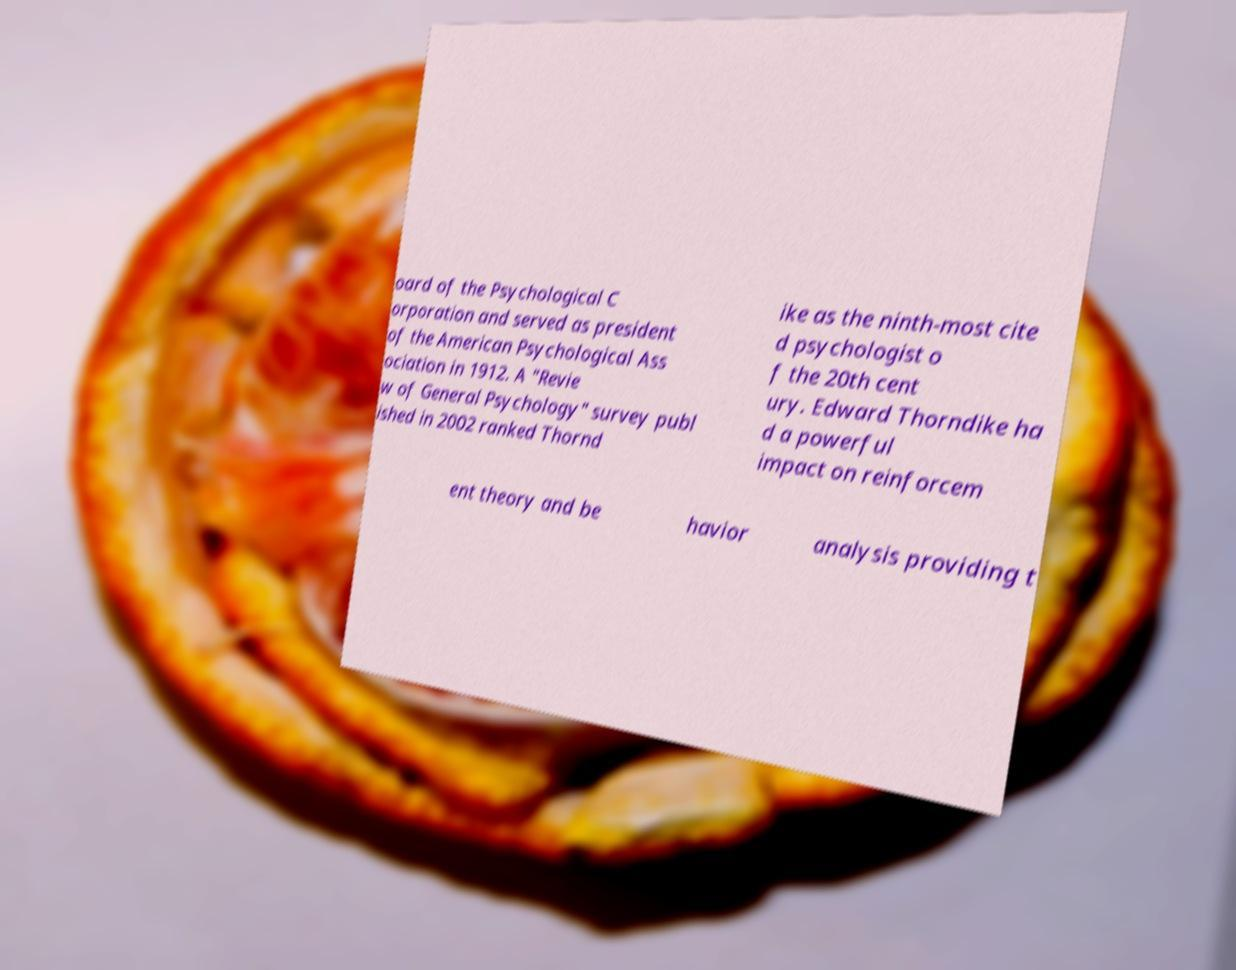Can you read and provide the text displayed in the image?This photo seems to have some interesting text. Can you extract and type it out for me? oard of the Psychological C orporation and served as president of the American Psychological Ass ociation in 1912. A "Revie w of General Psychology" survey publ ished in 2002 ranked Thornd ike as the ninth-most cite d psychologist o f the 20th cent ury. Edward Thorndike ha d a powerful impact on reinforcem ent theory and be havior analysis providing t 